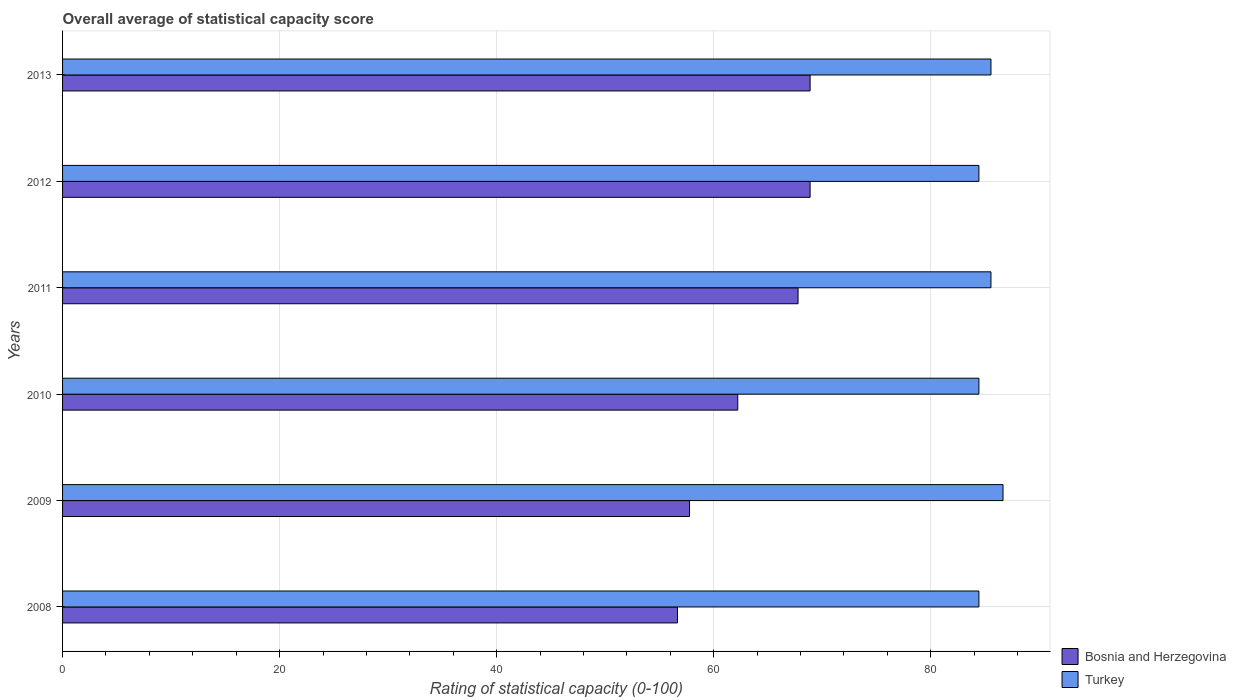How many different coloured bars are there?
Provide a short and direct response. 2. How many bars are there on the 1st tick from the top?
Your response must be concise. 2. What is the label of the 3rd group of bars from the top?
Your response must be concise. 2011. What is the rating of statistical capacity in Turkey in 2008?
Your response must be concise. 84.44. Across all years, what is the maximum rating of statistical capacity in Bosnia and Herzegovina?
Keep it short and to the point. 68.89. Across all years, what is the minimum rating of statistical capacity in Bosnia and Herzegovina?
Your answer should be very brief. 56.67. In which year was the rating of statistical capacity in Turkey maximum?
Ensure brevity in your answer.  2009. What is the total rating of statistical capacity in Bosnia and Herzegovina in the graph?
Offer a very short reply. 382.22. What is the difference between the rating of statistical capacity in Turkey in 2009 and that in 2010?
Give a very brief answer. 2.22. What is the difference between the rating of statistical capacity in Turkey in 2009 and the rating of statistical capacity in Bosnia and Herzegovina in 2011?
Give a very brief answer. 18.89. What is the average rating of statistical capacity in Bosnia and Herzegovina per year?
Ensure brevity in your answer.  63.7. In the year 2008, what is the difference between the rating of statistical capacity in Bosnia and Herzegovina and rating of statistical capacity in Turkey?
Offer a terse response. -27.78. In how many years, is the rating of statistical capacity in Bosnia and Herzegovina greater than 64 ?
Offer a terse response. 3. What is the ratio of the rating of statistical capacity in Bosnia and Herzegovina in 2008 to that in 2010?
Ensure brevity in your answer.  0.91. Is the difference between the rating of statistical capacity in Bosnia and Herzegovina in 2009 and 2011 greater than the difference between the rating of statistical capacity in Turkey in 2009 and 2011?
Your answer should be compact. No. What is the difference between the highest and the second highest rating of statistical capacity in Turkey?
Provide a short and direct response. 1.11. What is the difference between the highest and the lowest rating of statistical capacity in Turkey?
Make the answer very short. 2.22. In how many years, is the rating of statistical capacity in Turkey greater than the average rating of statistical capacity in Turkey taken over all years?
Your answer should be compact. 3. What does the 1st bar from the top in 2013 represents?
Your answer should be compact. Turkey. What does the 2nd bar from the bottom in 2011 represents?
Provide a succinct answer. Turkey. Are all the bars in the graph horizontal?
Your answer should be compact. Yes. What is the difference between two consecutive major ticks on the X-axis?
Your response must be concise. 20. Are the values on the major ticks of X-axis written in scientific E-notation?
Your answer should be compact. No. Does the graph contain grids?
Offer a very short reply. Yes. How many legend labels are there?
Offer a very short reply. 2. What is the title of the graph?
Provide a short and direct response. Overall average of statistical capacity score. What is the label or title of the X-axis?
Provide a short and direct response. Rating of statistical capacity (0-100). What is the Rating of statistical capacity (0-100) in Bosnia and Herzegovina in 2008?
Provide a succinct answer. 56.67. What is the Rating of statistical capacity (0-100) in Turkey in 2008?
Give a very brief answer. 84.44. What is the Rating of statistical capacity (0-100) in Bosnia and Herzegovina in 2009?
Keep it short and to the point. 57.78. What is the Rating of statistical capacity (0-100) in Turkey in 2009?
Your answer should be very brief. 86.67. What is the Rating of statistical capacity (0-100) in Bosnia and Herzegovina in 2010?
Give a very brief answer. 62.22. What is the Rating of statistical capacity (0-100) in Turkey in 2010?
Your response must be concise. 84.44. What is the Rating of statistical capacity (0-100) of Bosnia and Herzegovina in 2011?
Your answer should be compact. 67.78. What is the Rating of statistical capacity (0-100) in Turkey in 2011?
Give a very brief answer. 85.56. What is the Rating of statistical capacity (0-100) in Bosnia and Herzegovina in 2012?
Your answer should be very brief. 68.89. What is the Rating of statistical capacity (0-100) in Turkey in 2012?
Keep it short and to the point. 84.44. What is the Rating of statistical capacity (0-100) in Bosnia and Herzegovina in 2013?
Give a very brief answer. 68.89. What is the Rating of statistical capacity (0-100) of Turkey in 2013?
Your answer should be very brief. 85.56. Across all years, what is the maximum Rating of statistical capacity (0-100) in Bosnia and Herzegovina?
Provide a short and direct response. 68.89. Across all years, what is the maximum Rating of statistical capacity (0-100) of Turkey?
Offer a terse response. 86.67. Across all years, what is the minimum Rating of statistical capacity (0-100) of Bosnia and Herzegovina?
Your answer should be compact. 56.67. Across all years, what is the minimum Rating of statistical capacity (0-100) of Turkey?
Your answer should be compact. 84.44. What is the total Rating of statistical capacity (0-100) of Bosnia and Herzegovina in the graph?
Provide a short and direct response. 382.22. What is the total Rating of statistical capacity (0-100) in Turkey in the graph?
Your response must be concise. 511.11. What is the difference between the Rating of statistical capacity (0-100) in Bosnia and Herzegovina in 2008 and that in 2009?
Your answer should be compact. -1.11. What is the difference between the Rating of statistical capacity (0-100) of Turkey in 2008 and that in 2009?
Offer a very short reply. -2.22. What is the difference between the Rating of statistical capacity (0-100) of Bosnia and Herzegovina in 2008 and that in 2010?
Offer a terse response. -5.56. What is the difference between the Rating of statistical capacity (0-100) in Bosnia and Herzegovina in 2008 and that in 2011?
Give a very brief answer. -11.11. What is the difference between the Rating of statistical capacity (0-100) of Turkey in 2008 and that in 2011?
Your answer should be very brief. -1.11. What is the difference between the Rating of statistical capacity (0-100) in Bosnia and Herzegovina in 2008 and that in 2012?
Give a very brief answer. -12.22. What is the difference between the Rating of statistical capacity (0-100) in Bosnia and Herzegovina in 2008 and that in 2013?
Your answer should be very brief. -12.22. What is the difference between the Rating of statistical capacity (0-100) in Turkey in 2008 and that in 2013?
Make the answer very short. -1.11. What is the difference between the Rating of statistical capacity (0-100) in Bosnia and Herzegovina in 2009 and that in 2010?
Your answer should be compact. -4.44. What is the difference between the Rating of statistical capacity (0-100) of Turkey in 2009 and that in 2010?
Give a very brief answer. 2.22. What is the difference between the Rating of statistical capacity (0-100) of Turkey in 2009 and that in 2011?
Your answer should be compact. 1.11. What is the difference between the Rating of statistical capacity (0-100) of Bosnia and Herzegovina in 2009 and that in 2012?
Give a very brief answer. -11.11. What is the difference between the Rating of statistical capacity (0-100) of Turkey in 2009 and that in 2012?
Keep it short and to the point. 2.22. What is the difference between the Rating of statistical capacity (0-100) in Bosnia and Herzegovina in 2009 and that in 2013?
Offer a terse response. -11.11. What is the difference between the Rating of statistical capacity (0-100) in Bosnia and Herzegovina in 2010 and that in 2011?
Provide a short and direct response. -5.56. What is the difference between the Rating of statistical capacity (0-100) in Turkey in 2010 and that in 2011?
Give a very brief answer. -1.11. What is the difference between the Rating of statistical capacity (0-100) of Bosnia and Herzegovina in 2010 and that in 2012?
Offer a very short reply. -6.67. What is the difference between the Rating of statistical capacity (0-100) in Turkey in 2010 and that in 2012?
Offer a very short reply. 0. What is the difference between the Rating of statistical capacity (0-100) of Bosnia and Herzegovina in 2010 and that in 2013?
Your answer should be very brief. -6.67. What is the difference between the Rating of statistical capacity (0-100) in Turkey in 2010 and that in 2013?
Ensure brevity in your answer.  -1.11. What is the difference between the Rating of statistical capacity (0-100) of Bosnia and Herzegovina in 2011 and that in 2012?
Provide a short and direct response. -1.11. What is the difference between the Rating of statistical capacity (0-100) in Bosnia and Herzegovina in 2011 and that in 2013?
Your answer should be compact. -1.11. What is the difference between the Rating of statistical capacity (0-100) in Turkey in 2012 and that in 2013?
Offer a very short reply. -1.11. What is the difference between the Rating of statistical capacity (0-100) in Bosnia and Herzegovina in 2008 and the Rating of statistical capacity (0-100) in Turkey in 2010?
Provide a succinct answer. -27.78. What is the difference between the Rating of statistical capacity (0-100) of Bosnia and Herzegovina in 2008 and the Rating of statistical capacity (0-100) of Turkey in 2011?
Provide a short and direct response. -28.89. What is the difference between the Rating of statistical capacity (0-100) of Bosnia and Herzegovina in 2008 and the Rating of statistical capacity (0-100) of Turkey in 2012?
Give a very brief answer. -27.78. What is the difference between the Rating of statistical capacity (0-100) in Bosnia and Herzegovina in 2008 and the Rating of statistical capacity (0-100) in Turkey in 2013?
Provide a succinct answer. -28.89. What is the difference between the Rating of statistical capacity (0-100) in Bosnia and Herzegovina in 2009 and the Rating of statistical capacity (0-100) in Turkey in 2010?
Provide a short and direct response. -26.67. What is the difference between the Rating of statistical capacity (0-100) of Bosnia and Herzegovina in 2009 and the Rating of statistical capacity (0-100) of Turkey in 2011?
Give a very brief answer. -27.78. What is the difference between the Rating of statistical capacity (0-100) in Bosnia and Herzegovina in 2009 and the Rating of statistical capacity (0-100) in Turkey in 2012?
Your answer should be very brief. -26.67. What is the difference between the Rating of statistical capacity (0-100) in Bosnia and Herzegovina in 2009 and the Rating of statistical capacity (0-100) in Turkey in 2013?
Give a very brief answer. -27.78. What is the difference between the Rating of statistical capacity (0-100) in Bosnia and Herzegovina in 2010 and the Rating of statistical capacity (0-100) in Turkey in 2011?
Offer a terse response. -23.33. What is the difference between the Rating of statistical capacity (0-100) of Bosnia and Herzegovina in 2010 and the Rating of statistical capacity (0-100) of Turkey in 2012?
Provide a short and direct response. -22.22. What is the difference between the Rating of statistical capacity (0-100) in Bosnia and Herzegovina in 2010 and the Rating of statistical capacity (0-100) in Turkey in 2013?
Provide a succinct answer. -23.33. What is the difference between the Rating of statistical capacity (0-100) of Bosnia and Herzegovina in 2011 and the Rating of statistical capacity (0-100) of Turkey in 2012?
Your answer should be compact. -16.67. What is the difference between the Rating of statistical capacity (0-100) of Bosnia and Herzegovina in 2011 and the Rating of statistical capacity (0-100) of Turkey in 2013?
Keep it short and to the point. -17.78. What is the difference between the Rating of statistical capacity (0-100) of Bosnia and Herzegovina in 2012 and the Rating of statistical capacity (0-100) of Turkey in 2013?
Provide a short and direct response. -16.67. What is the average Rating of statistical capacity (0-100) in Bosnia and Herzegovina per year?
Provide a succinct answer. 63.7. What is the average Rating of statistical capacity (0-100) in Turkey per year?
Ensure brevity in your answer.  85.19. In the year 2008, what is the difference between the Rating of statistical capacity (0-100) in Bosnia and Herzegovina and Rating of statistical capacity (0-100) in Turkey?
Your answer should be very brief. -27.78. In the year 2009, what is the difference between the Rating of statistical capacity (0-100) in Bosnia and Herzegovina and Rating of statistical capacity (0-100) in Turkey?
Your response must be concise. -28.89. In the year 2010, what is the difference between the Rating of statistical capacity (0-100) in Bosnia and Herzegovina and Rating of statistical capacity (0-100) in Turkey?
Offer a terse response. -22.22. In the year 2011, what is the difference between the Rating of statistical capacity (0-100) in Bosnia and Herzegovina and Rating of statistical capacity (0-100) in Turkey?
Offer a very short reply. -17.78. In the year 2012, what is the difference between the Rating of statistical capacity (0-100) in Bosnia and Herzegovina and Rating of statistical capacity (0-100) in Turkey?
Offer a terse response. -15.56. In the year 2013, what is the difference between the Rating of statistical capacity (0-100) in Bosnia and Herzegovina and Rating of statistical capacity (0-100) in Turkey?
Make the answer very short. -16.67. What is the ratio of the Rating of statistical capacity (0-100) of Bosnia and Herzegovina in 2008 to that in 2009?
Offer a very short reply. 0.98. What is the ratio of the Rating of statistical capacity (0-100) of Turkey in 2008 to that in 2009?
Ensure brevity in your answer.  0.97. What is the ratio of the Rating of statistical capacity (0-100) of Bosnia and Herzegovina in 2008 to that in 2010?
Offer a very short reply. 0.91. What is the ratio of the Rating of statistical capacity (0-100) of Turkey in 2008 to that in 2010?
Provide a succinct answer. 1. What is the ratio of the Rating of statistical capacity (0-100) of Bosnia and Herzegovina in 2008 to that in 2011?
Give a very brief answer. 0.84. What is the ratio of the Rating of statistical capacity (0-100) in Bosnia and Herzegovina in 2008 to that in 2012?
Your response must be concise. 0.82. What is the ratio of the Rating of statistical capacity (0-100) in Turkey in 2008 to that in 2012?
Your response must be concise. 1. What is the ratio of the Rating of statistical capacity (0-100) of Bosnia and Herzegovina in 2008 to that in 2013?
Your answer should be compact. 0.82. What is the ratio of the Rating of statistical capacity (0-100) of Turkey in 2009 to that in 2010?
Your response must be concise. 1.03. What is the ratio of the Rating of statistical capacity (0-100) in Bosnia and Herzegovina in 2009 to that in 2011?
Provide a short and direct response. 0.85. What is the ratio of the Rating of statistical capacity (0-100) in Bosnia and Herzegovina in 2009 to that in 2012?
Offer a very short reply. 0.84. What is the ratio of the Rating of statistical capacity (0-100) in Turkey in 2009 to that in 2012?
Offer a terse response. 1.03. What is the ratio of the Rating of statistical capacity (0-100) of Bosnia and Herzegovina in 2009 to that in 2013?
Offer a terse response. 0.84. What is the ratio of the Rating of statistical capacity (0-100) in Bosnia and Herzegovina in 2010 to that in 2011?
Provide a short and direct response. 0.92. What is the ratio of the Rating of statistical capacity (0-100) in Bosnia and Herzegovina in 2010 to that in 2012?
Make the answer very short. 0.9. What is the ratio of the Rating of statistical capacity (0-100) of Turkey in 2010 to that in 2012?
Give a very brief answer. 1. What is the ratio of the Rating of statistical capacity (0-100) in Bosnia and Herzegovina in 2010 to that in 2013?
Offer a very short reply. 0.9. What is the ratio of the Rating of statistical capacity (0-100) of Bosnia and Herzegovina in 2011 to that in 2012?
Provide a short and direct response. 0.98. What is the ratio of the Rating of statistical capacity (0-100) of Turkey in 2011 to that in 2012?
Your answer should be very brief. 1.01. What is the ratio of the Rating of statistical capacity (0-100) in Bosnia and Herzegovina in 2011 to that in 2013?
Make the answer very short. 0.98. What is the ratio of the Rating of statistical capacity (0-100) in Bosnia and Herzegovina in 2012 to that in 2013?
Your answer should be compact. 1. What is the difference between the highest and the second highest Rating of statistical capacity (0-100) in Bosnia and Herzegovina?
Keep it short and to the point. 0. What is the difference between the highest and the second highest Rating of statistical capacity (0-100) in Turkey?
Your response must be concise. 1.11. What is the difference between the highest and the lowest Rating of statistical capacity (0-100) in Bosnia and Herzegovina?
Your response must be concise. 12.22. What is the difference between the highest and the lowest Rating of statistical capacity (0-100) of Turkey?
Offer a very short reply. 2.22. 